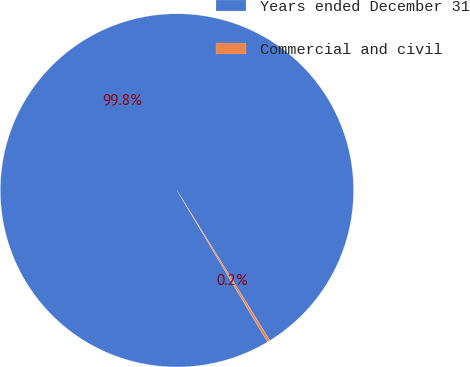Convert chart. <chart><loc_0><loc_0><loc_500><loc_500><pie_chart><fcel>Years ended December 31<fcel>Commercial and civil<nl><fcel>99.75%<fcel>0.25%<nl></chart> 